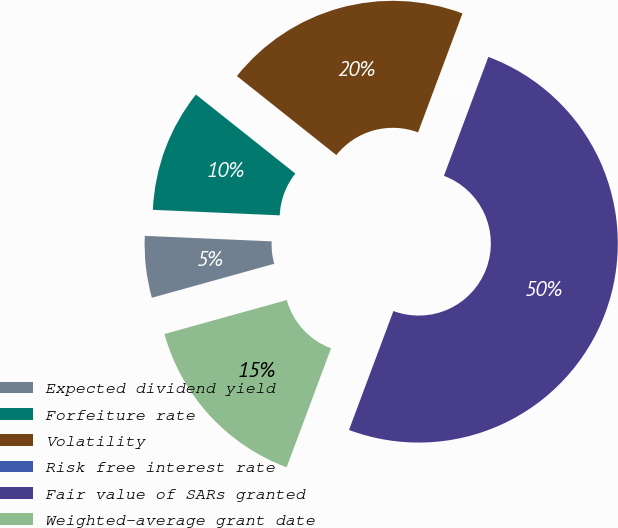<chart> <loc_0><loc_0><loc_500><loc_500><pie_chart><fcel>Expected dividend yield<fcel>Forfeiture rate<fcel>Volatility<fcel>Risk free interest rate<fcel>Fair value of SARs granted<fcel>Weighted-average grant date<nl><fcel>5.0%<fcel>10.0%<fcel>20.0%<fcel>0.0%<fcel>50.0%<fcel>15.0%<nl></chart> 